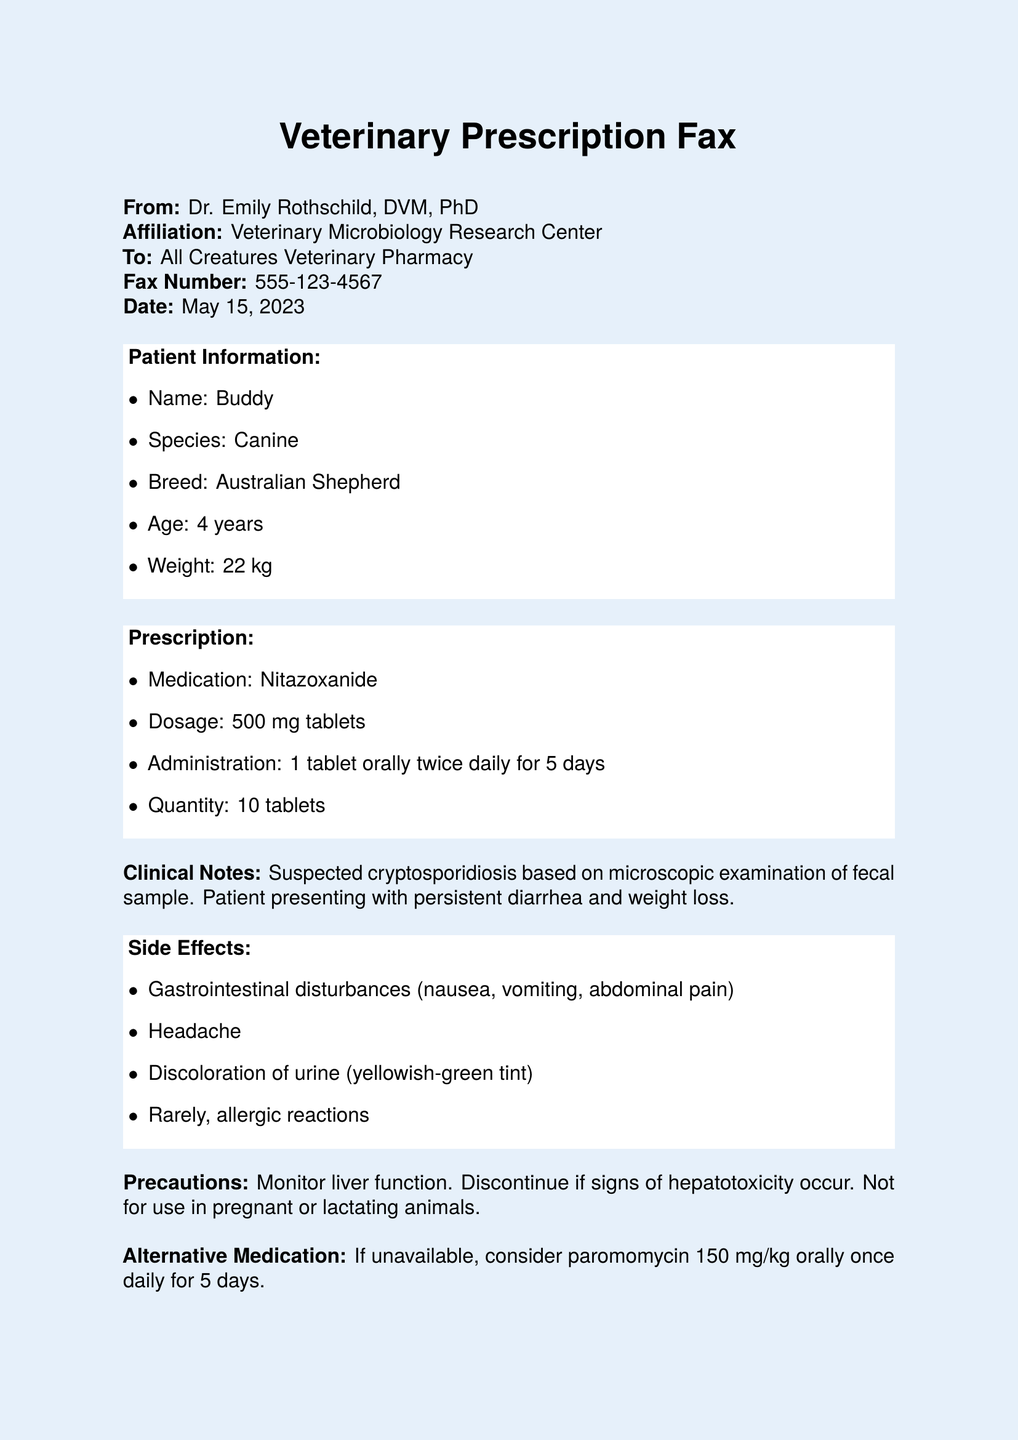What is the name of the patient? The document provides the patient's name under the Patient Information section, which is Buddy.
Answer: Buddy What is the species of the patient? The species of the patient is listed in the Patient Information section, which is Canine.
Answer: Canine What is the medication prescribed? The medication is found in the Prescription section, and it states Nitazoxanide.
Answer: Nitazoxanide What is the dosage of the medication? The dosage of the medication is specified in the Prescription section as 500 mg tablets.
Answer: 500 mg tablets How many tablets were prescribed? The quantity of tablets is clearly stated in the Prescription section, which mentions 10 tablets.
Answer: 10 tablets What are the potential side effects listed? The potential side effects are outlined in the Side Effects section, including gastrointestinal disturbances and allergic reactions.
Answer: Gastrointestinal disturbances, headache, discoloration of urine, allergic reactions What is the duration of the medication administration? The duration is mentioned in the administration instructions, indicating for 5 days.
Answer: 5 days What precaution is noted regarding the use of the medication? The document includes a precaution that states to monitor liver function.
Answer: Monitor liver function What is the alternative medication suggested? The alternative medication is found in the document, which suggests paromomycin if Nitazoxanide is unavailable.
Answer: Paromomycin Who is the prescribing veterinarian? The veterinarian's name is provided at the bottom of the document, which is Dr. Emily Rothschild.
Answer: Dr. Emily Rothschild 